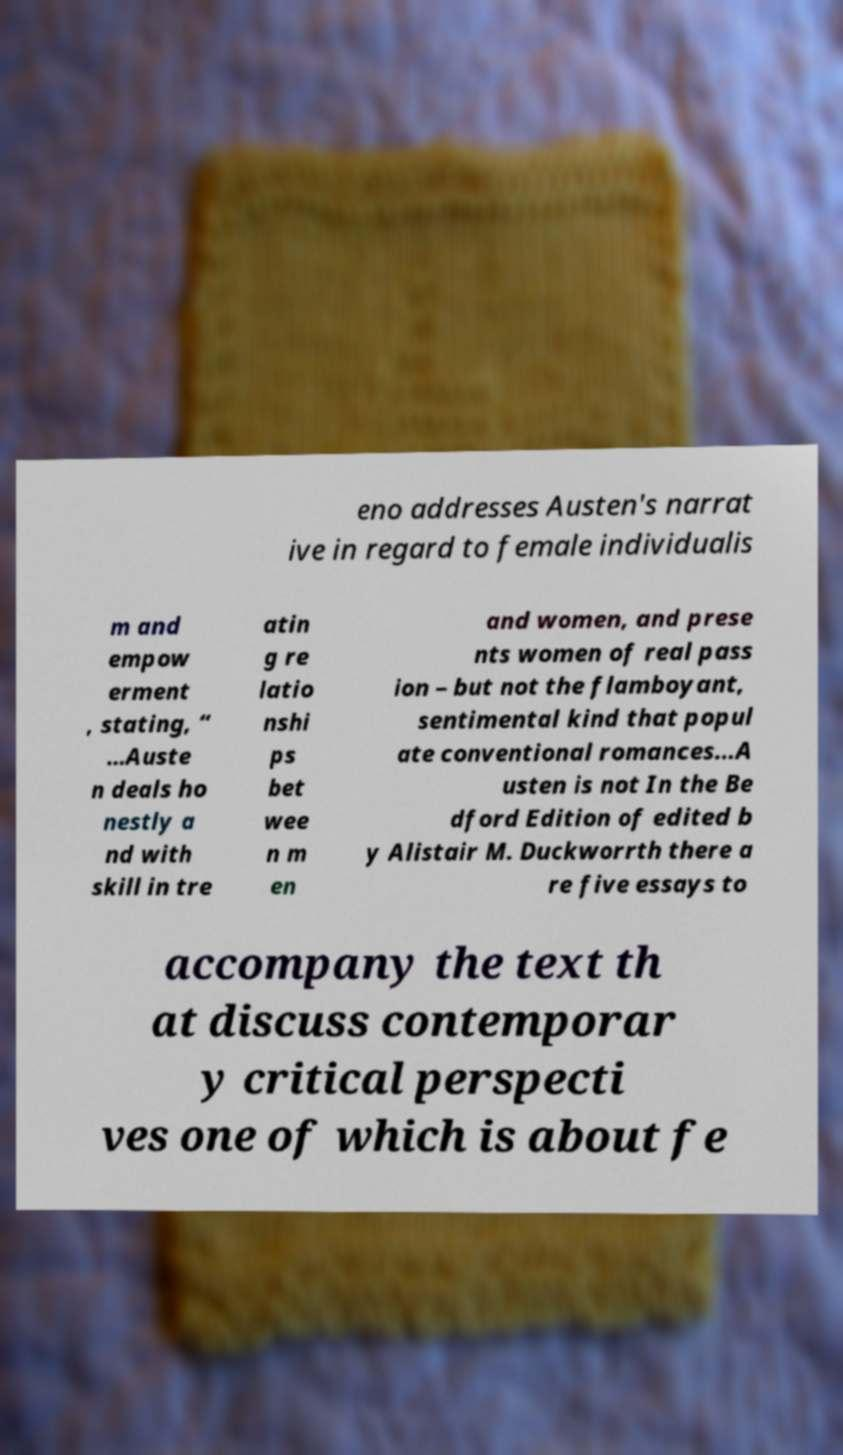Please read and relay the text visible in this image. What does it say? eno addresses Austen's narrat ive in regard to female individualis m and empow erment , stating, “ …Auste n deals ho nestly a nd with skill in tre atin g re latio nshi ps bet wee n m en and women, and prese nts women of real pass ion – but not the flamboyant, sentimental kind that popul ate conventional romances...A usten is not In the Be dford Edition of edited b y Alistair M. Duckworrth there a re five essays to accompany the text th at discuss contemporar y critical perspecti ves one of which is about fe 